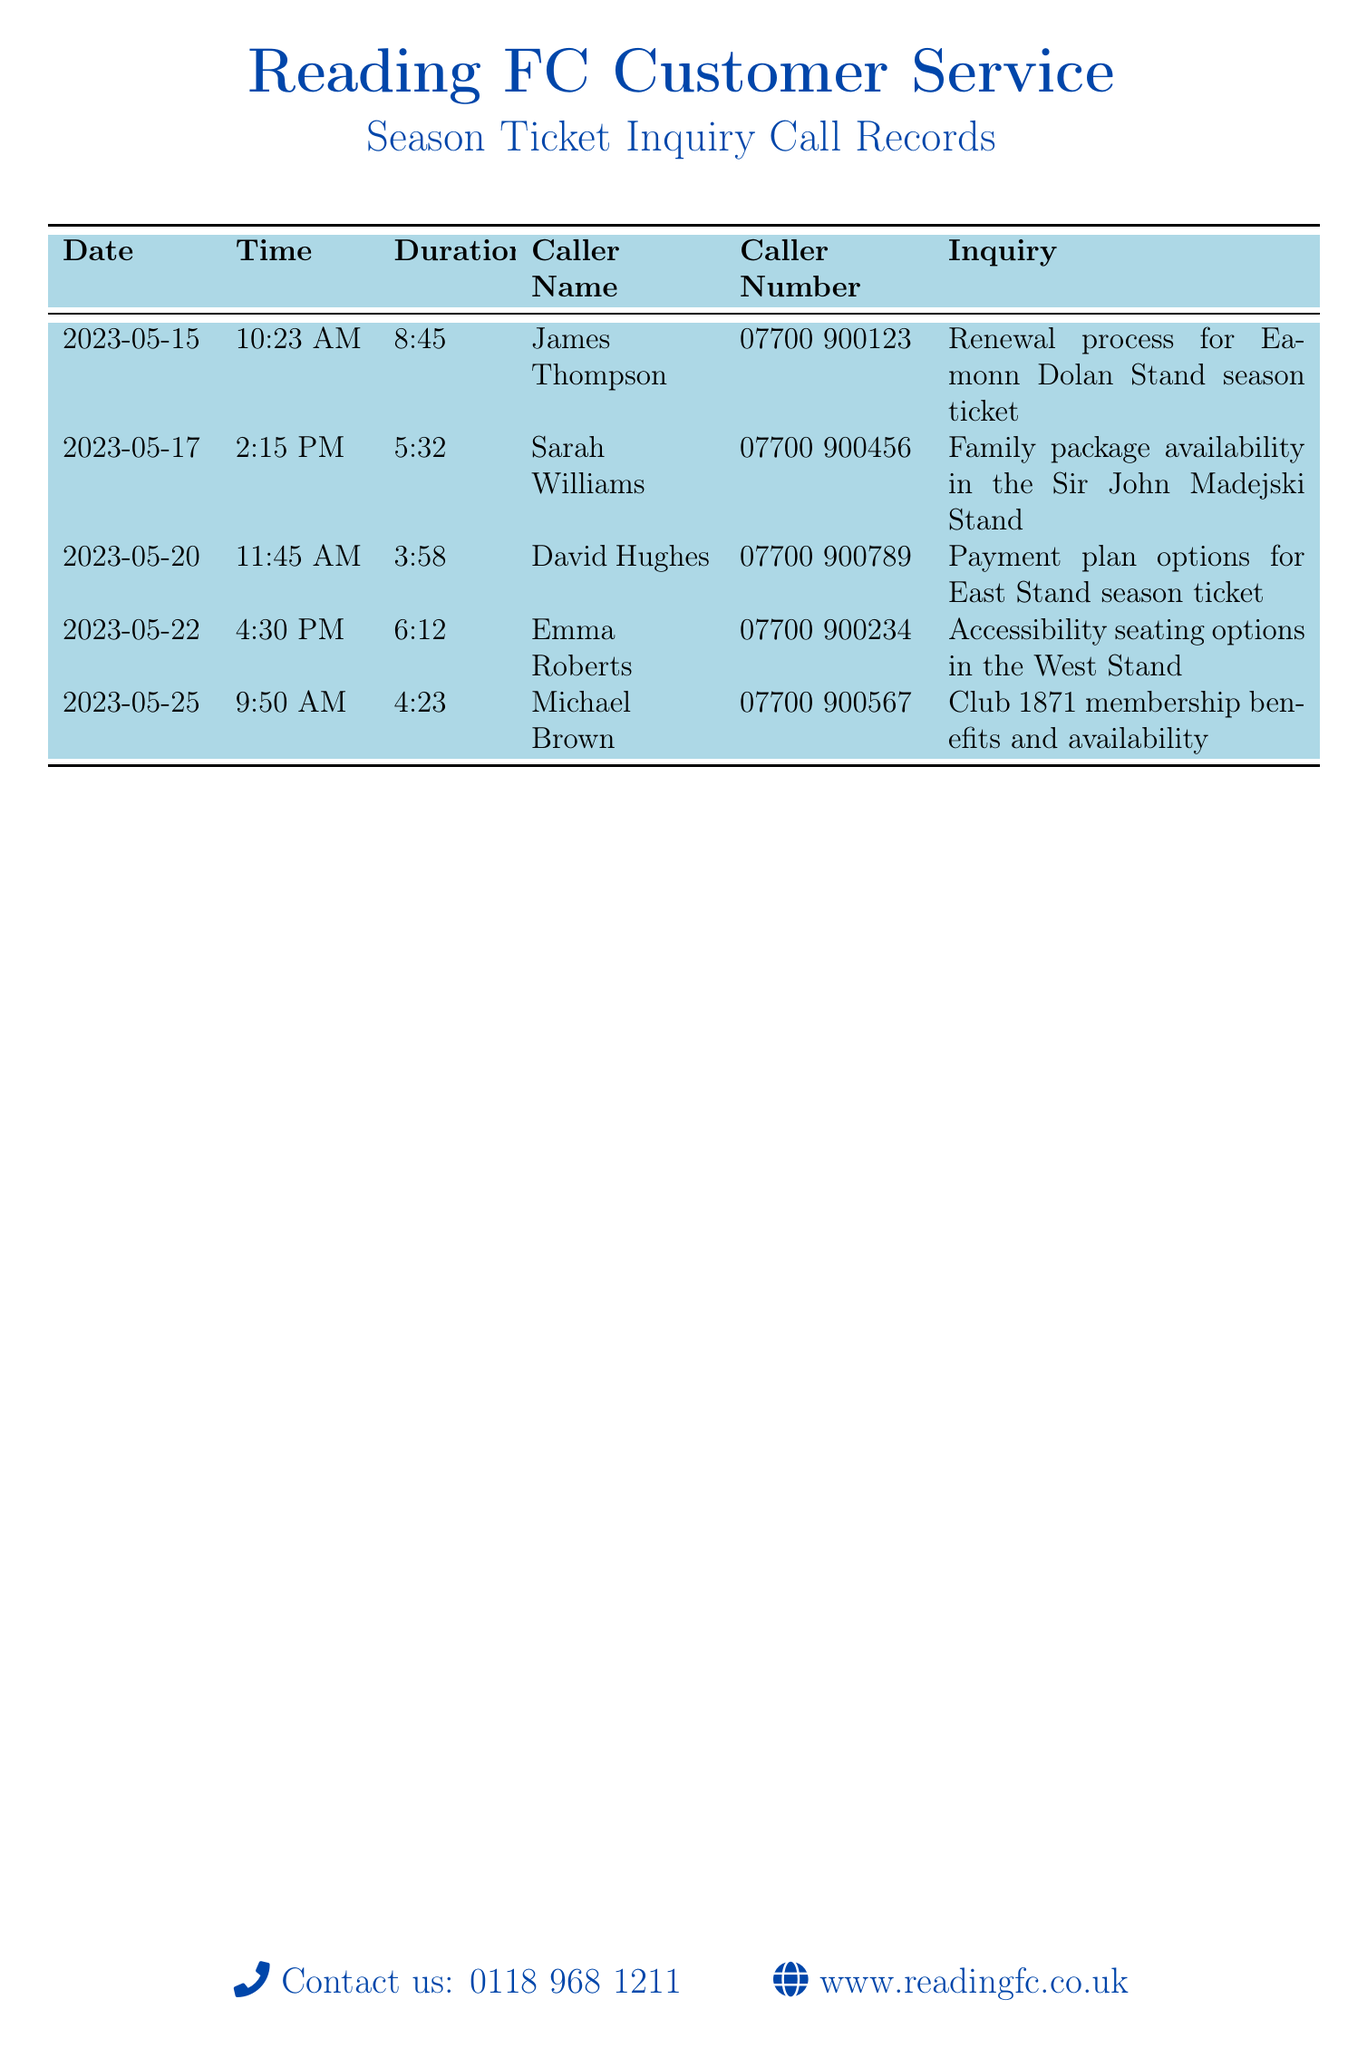What is the date of Michael Brown's call? The document lists the date of Michael Brown's call as May 25, 2023.
Answer: May 25, 2023 How long did Emma Roberts' call last? The duration of Emma Roberts' call is recorded as 6 minutes and 12 seconds.
Answer: 6:12 Which stand is associated with David Hughes' inquiry? David Hughes inquired about payment plan options specifically for the East Stand season ticket.
Answer: East Stand How many inquiries were made regarding seating options? There are two inquiries related to seating options: accessibility seating in the West Stand and renewal process for the Eamonn Dolan Stand.
Answer: 2 Who inquired about the family package? The family package availability was inquired about by Sarah Williams.
Answer: Sarah Williams What time did James Thompson call? The document notes that James Thompson's call was made at 10:23 AM.
Answer: 10:23 AM 